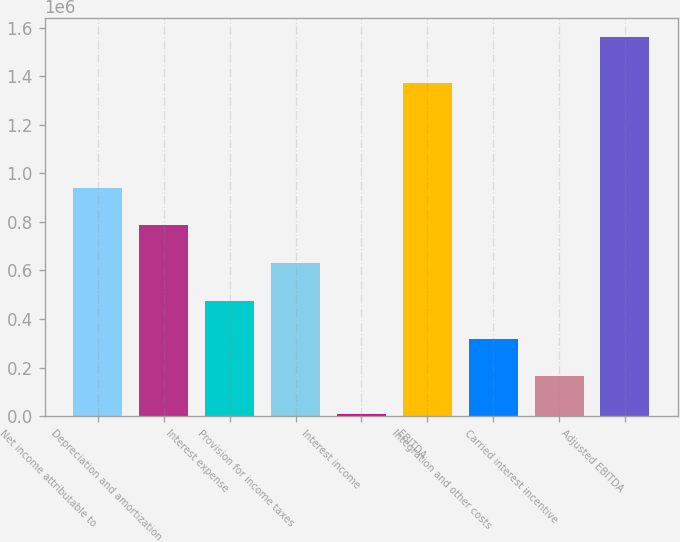Convert chart. <chart><loc_0><loc_0><loc_500><loc_500><bar_chart><fcel>Net income attributable to<fcel>Depreciation and amortization<fcel>Interest expense<fcel>Provision for income taxes<fcel>Interest income<fcel>EBITDA<fcel>Integration and other costs<fcel>Carried interest incentive<fcel>Adjusted EBITDA<nl><fcel>940629<fcel>785199<fcel>474340<fcel>629769<fcel>8051<fcel>1.37371e+06<fcel>318910<fcel>163481<fcel>1.56235e+06<nl></chart> 